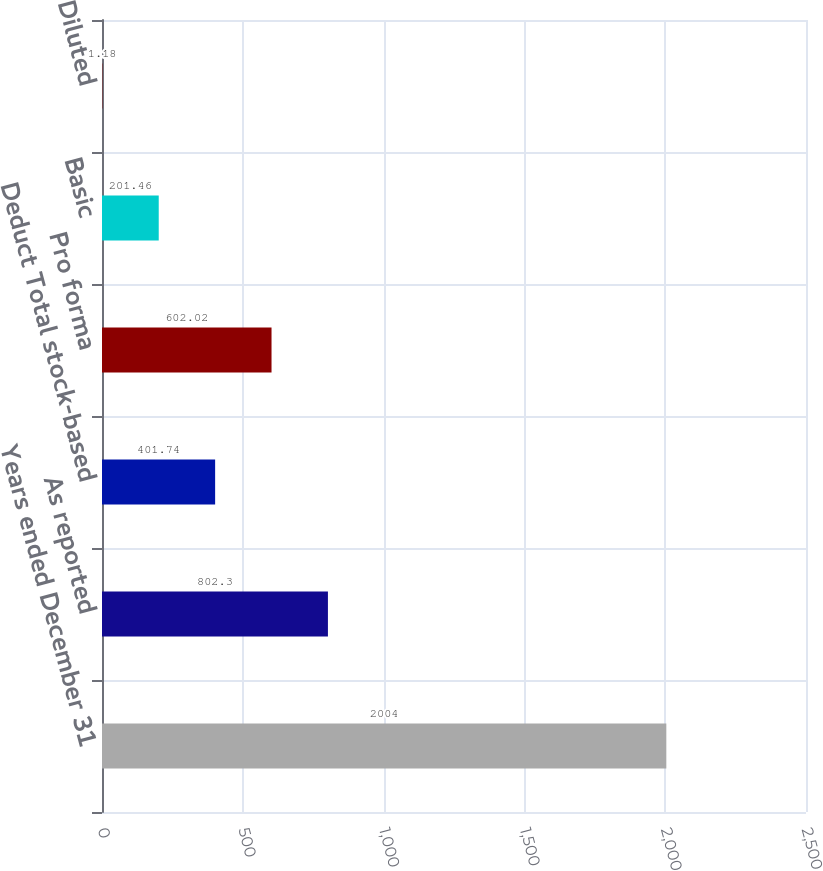<chart> <loc_0><loc_0><loc_500><loc_500><bar_chart><fcel>Years ended December 31<fcel>As reported<fcel>Deduct Total stock-based<fcel>Pro forma<fcel>Basic<fcel>Diluted<nl><fcel>2004<fcel>802.3<fcel>401.74<fcel>602.02<fcel>201.46<fcel>1.18<nl></chart> 